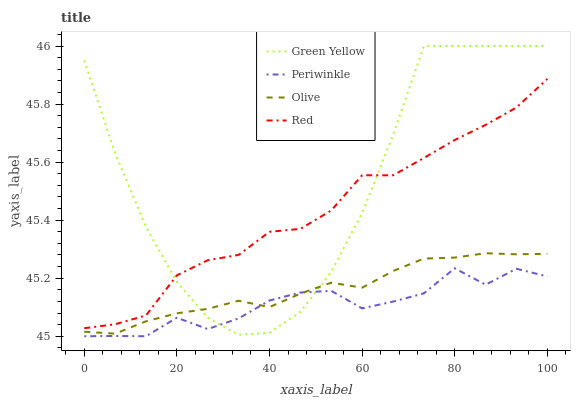Does Green Yellow have the minimum area under the curve?
Answer yes or no. No. Does Periwinkle have the maximum area under the curve?
Answer yes or no. No. Is Periwinkle the smoothest?
Answer yes or no. No. Is Periwinkle the roughest?
Answer yes or no. No. Does Green Yellow have the lowest value?
Answer yes or no. No. Does Periwinkle have the highest value?
Answer yes or no. No. Is Periwinkle less than Red?
Answer yes or no. Yes. Is Red greater than Olive?
Answer yes or no. Yes. Does Periwinkle intersect Red?
Answer yes or no. No. 